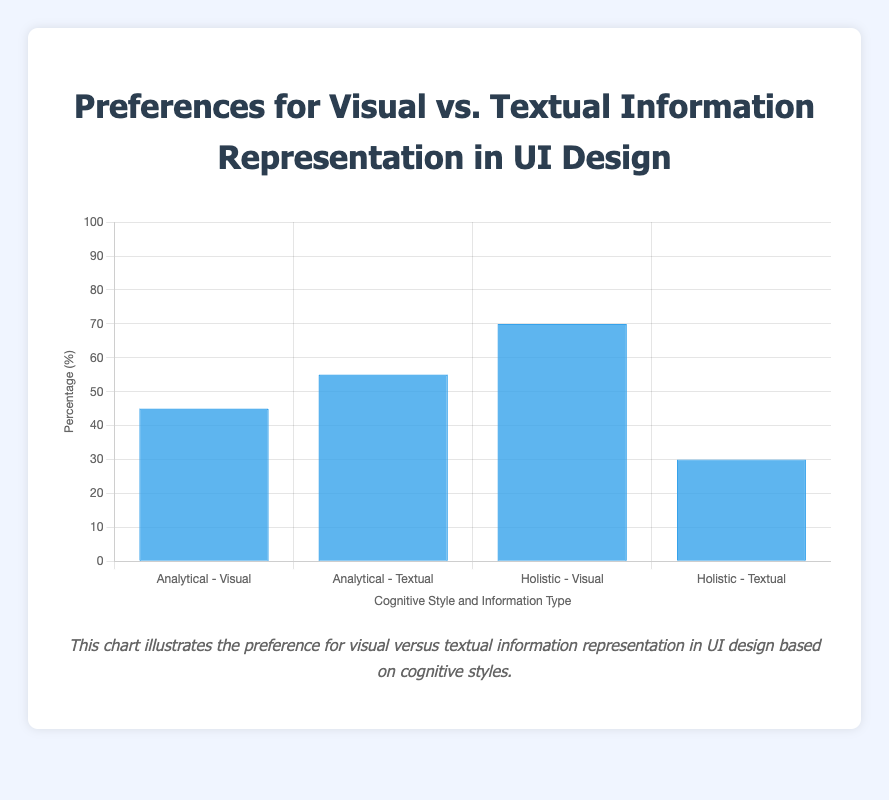Which cognitive style has the highest preference for visual information? To find the answer, look at the heights of the bars corresponding to the preference for Visual Information. The Holistic - Visual bar is higher (70%) than the Analytical - Visual bar (45%).
Answer: Holistic Which preference has a higher percentage for analytical cognitive style, visual or textual information? Compare the heights of the two bars under Analytical. The Analytical - Textual bar is 55%, while the Analytical - Visual bar is 45%.
Answer: Textual What is the difference in preference for visual information between holistic and analytical cognitive styles? Subtract the percentage of Analytical - Visual (45%) from Holistic - Visual (70%). 70% - 45% = 25%.
Answer: 25% What is the combined percentage of preferences for textual information across both cognitive styles? Add the percentages of Analytical - Textual (55%) and Holistic - Textual (30%). 55% + 30% = 85%.
Answer: 85% Which cognitive style shows a greater preference for visual information compared to textual information? For each cognitive style, compare the percentages of Visual and Textual preferences. Holistic has 70% for Visual and 30% for Textual, indicating Holistic shows a greater preference for Visual compared to Textual.
Answer: Holistic What is the average preference percentage for visual information across both cognitive styles? Add the percentages of Analytical - Visual (45%) and Holistic - Visual (70%) and then divide by 2. (45% + 70%) / 2 = 57.5%.
Answer: 57.5% How much more does the holistic cognitive style prefer visual information over textual information? Subtract the Holistic - Textual percentage (30%) from Holistic - Visual percentage (70%). 70% - 30% = 40%.
Answer: 40% Which cognitive style shows a closer balance between preferences for visual and textual information? Compare the differences between the visual and textual percentages for each style. Analytical has a difference of 10% (55% - 45%), and Holistic has a difference of 40% (70% - 30%). Analytical shows a closer balance.
Answer: Analytical What are the visual characteristics of the bar representing the holistic preference for visual information? The bar is blue, it is the tallest among all bars, and represents 70%.
Answer: Blue bar, tallest, 70% 